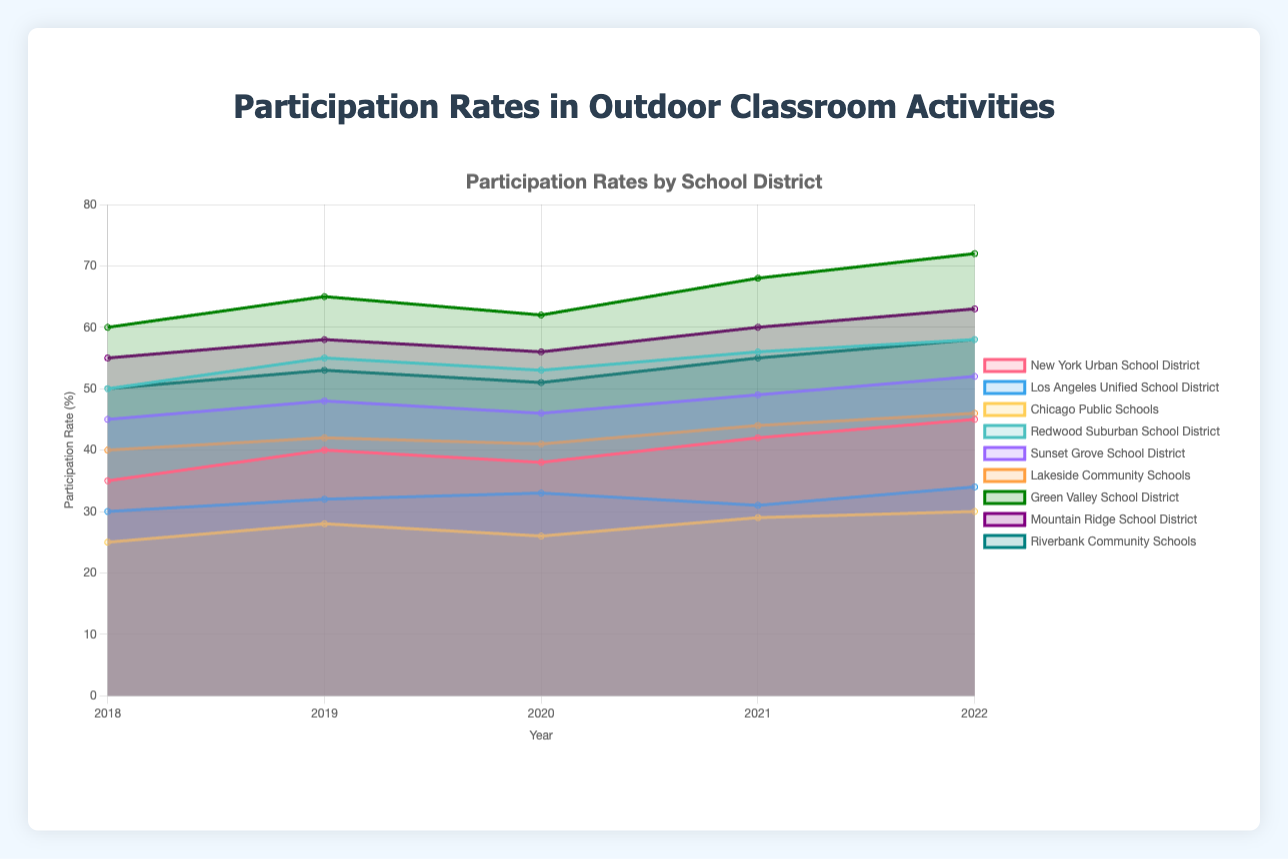What is the title of the chart? The title of the chart is prominently displayed at the top, which is "Participation Rates in Outdoor Classroom Activities".
Answer: Participation Rates in Outdoor Classroom Activities Which school district has the highest participation rate in 2022? To determine which school district has the highest participation rate in 2022, you can identify the bar or line segment that reaches the highest point on the y-axis for that year. The Green Valley School District has the highest participation rate.
Answer: Green Valley School District How did the participation rate of New York Urban School District change from 2018 to 2022? To understand the change over the years, look at the New York Urban School District's participation rates for each year from 2018 (35%) to 2022 (45%). The rate increased from 35% to 45%.
Answer: It increased from 35% to 45% Compare the participation rates of Los Angeles Unified School District and Chicago Public Schools in 2019. Which had a higher participation rate? Look at the data points for both districts in 2019. The Los Angeles Unified School District had a participation rate of 32%, while Chicago Public Schools had a rate of 28%. Thus, the Los Angeles Unified School District had a higher rate.
Answer: Los Angeles Unified School District What trend can you observe for Suburban Schools' participation rates from 2018 to 2022? Observe the combined trend of Redwood Suburban School District, Sunset Grove School District, and Lakeside Community Schools from 2018 to 2022. All show a general upward trend in participation rates over the years.
Answer: Upward trend Which district experienced the maximum increase in participation rate from 2020 to 2022? To determine this, calculate the difference in participation rates from 2020 to 2022 for each district. Green Valley School District: 72 - 62 = 10%, Mountain Ridge School District: 63 - 56 = 7%, etc. Green Valley School District had the maximum increase, which is 10%.
Answer: Green Valley School District What is the average participation rate of Suburban Schools in 2021? First, find the participation rates for all suburban districts in 2021: Redwood Suburban School District (56%), Sunset Grove School District (49%), and Lakeside Community Schools (44%). Then, calculate the average: (56 + 49 + 44) / 3 = 49.67%.
Answer: 49.67% Between 2018 and 2019, which district saw the largest decrease in participation rate? Calculate the difference between the participation rates for each district between 2018 and 2019. The largest decrease was in the Los Angeles Unified School District, which dropped from 30% to 32%, a decrease of 2%.
Answer: Los Angeles Unified School District For Rural Schools, what was the total participation rate in 2020? Add the participation rates for all rural districts in 2020: Green Valley (62), Mountain Ridge (56), Riverbank Community Schools (51). The total participation rate is 62 + 56 + 51 = 169.
Answer: 169 